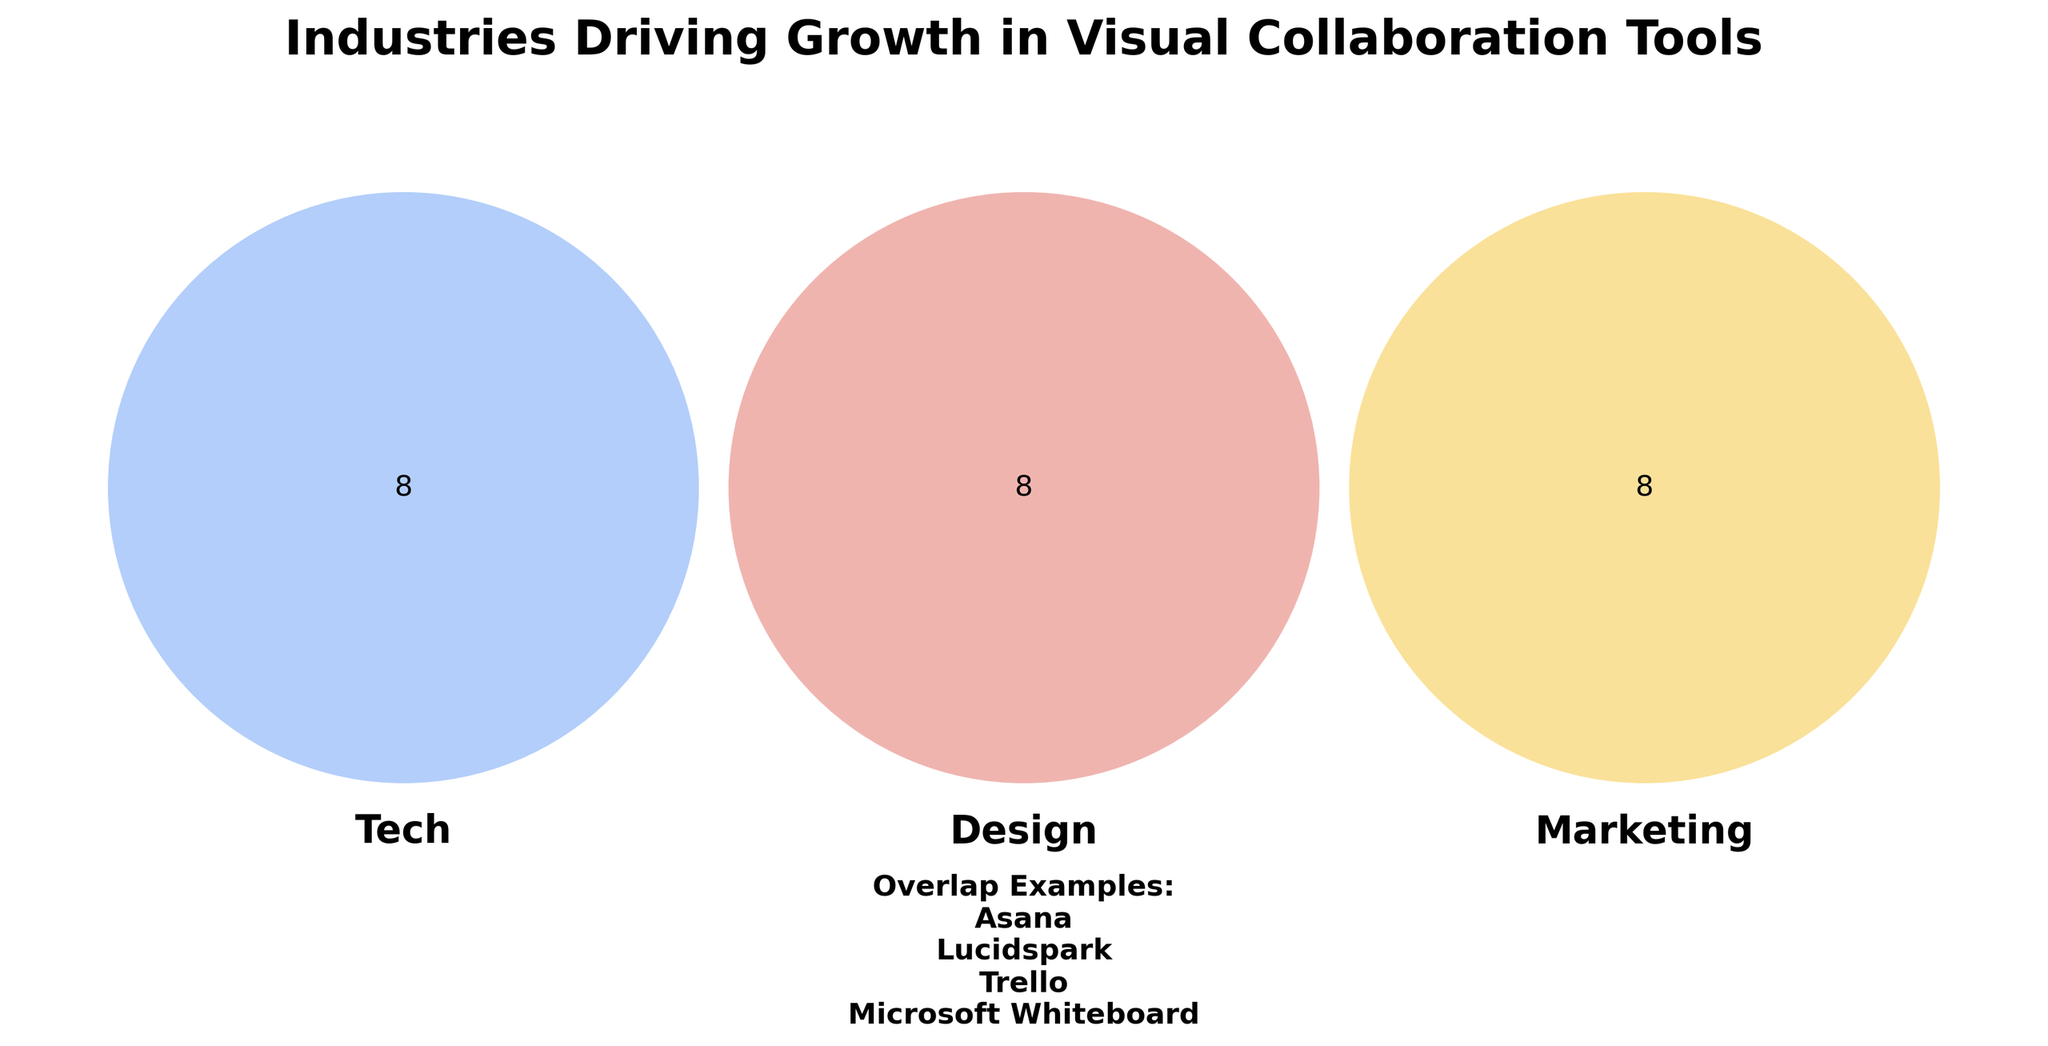What are the three industries shown in the Venn diagram? The title and set labels of the Venn diagram show the industries driving growth in visual collaboration tools.
Answer: Tech, Design, Marketing How many visual collaboration tools are listed under the Marketing category? The Marketing category has eight tools listed: Canva, HubSpot, Mailchimp, Hootsuite, Sprout Social, Buffer, SEMrush, and Ahrefs.
Answer: 8 Which visual collaboration tools fall into the overlap category? From the provided data, the overlap category includes Miro, Slack, Trello, Asana, Notion, Microsoft Whiteboard, Conceptboard, and Lucidspark.
Answer: 8 How many tools are shared between the three industries (Tech, Design, and Marketing)? Finding the shared tools requires counting those listed under the overlap category in the provided data.
Answer: 8 What color represents the Design category in the Venn diagram? Observing the set labels in the diagram, the Design category is represented with red.
Answer: Red Which of the following sets has the least number of tools: Tech, Design, or Marketing? Counting the tools in each set we find: Tech has 8, Design has 8, Marketing has 8. Thus, all sets have the same number.
Answer: All equal Which tool appears in both the Design and Marketing categories but not in Tech? Observing the provided data, no specific tool is listed that fits this exact description.
Answer: None List one tool that is only in the Tech category and not overlapping with others. From the data, BlueJeans is a tool that appears exclusively in the Tech category without overlap.
Answer: BlueJeans Which visual collaboration tool appears in all three categories? By referring to the overlap examples, Miro, Slack, Trello, Asana falls within all three categories.
Answer: Miro, Slack, Trello, Asana 